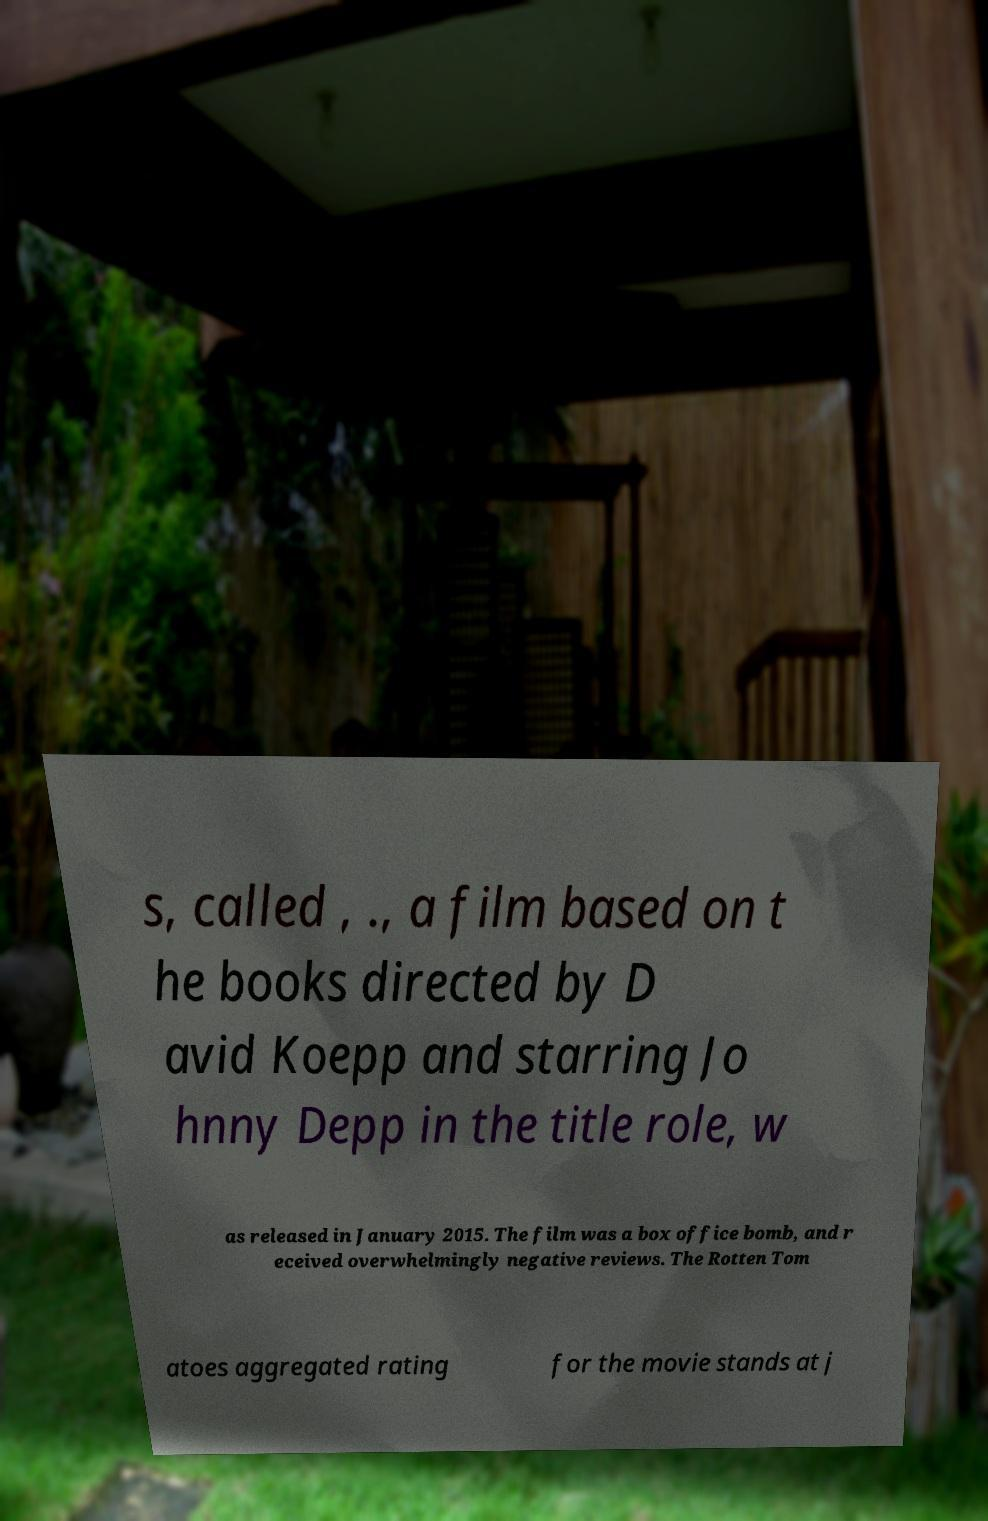Please read and relay the text visible in this image. What does it say? s, called , ., a film based on t he books directed by D avid Koepp and starring Jo hnny Depp in the title role, w as released in January 2015. The film was a box office bomb, and r eceived overwhelmingly negative reviews. The Rotten Tom atoes aggregated rating for the movie stands at j 